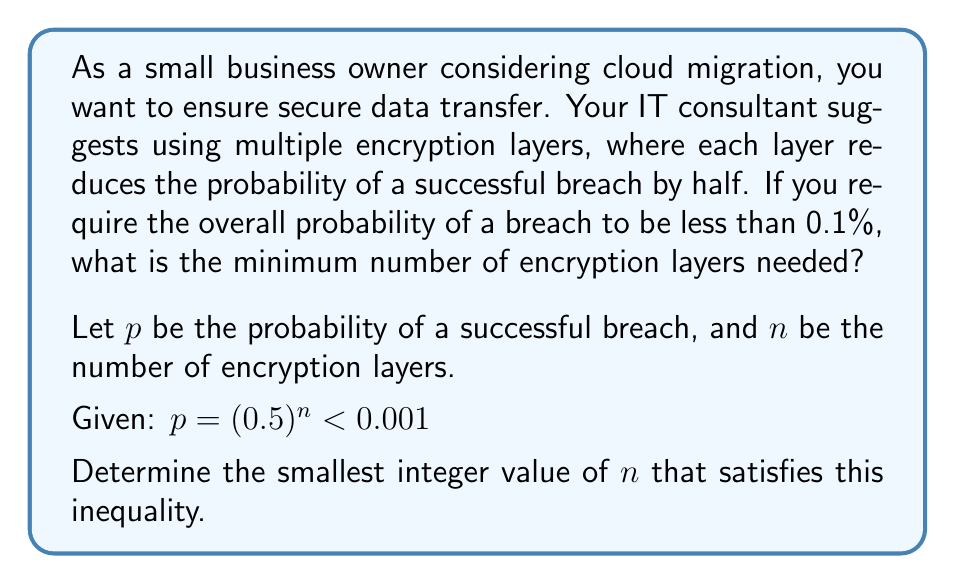Give your solution to this math problem. To solve this problem, we need to follow these steps:

1) Start with the given inequality:
   $$(0.5)^n < 0.001$$

2) Take the logarithm (base 2) of both sides:
   $$\log_2((0.5)^n) < \log_2(0.001)$$

3) Using the logarithm property $\log_a(x^n) = n\log_a(x)$:
   $$n \log_2(0.5) < \log_2(0.001)$$

4) Simplify $\log_2(0.5) = -1$:
   $$-n < \log_2(0.001)$$

5) Multiply both sides by -1 (flip the inequality sign):
   $$n > -\log_2(0.001)$$

6) Calculate $-\log_2(0.001)$:
   $$n > 9.965784284662087$$

7) Since $n$ must be an integer, we round up to the nearest whole number:
   $$n \geq 10$$

Therefore, the minimum number of encryption layers needed is 10.

To verify:
$$(0.5)^{10} = 0.0009765625 < 0.001$$

This confirms that 10 layers are sufficient to reduce the probability of a breach to less than 0.1%.
Answer: The minimum number of encryption layers needed is 10. 